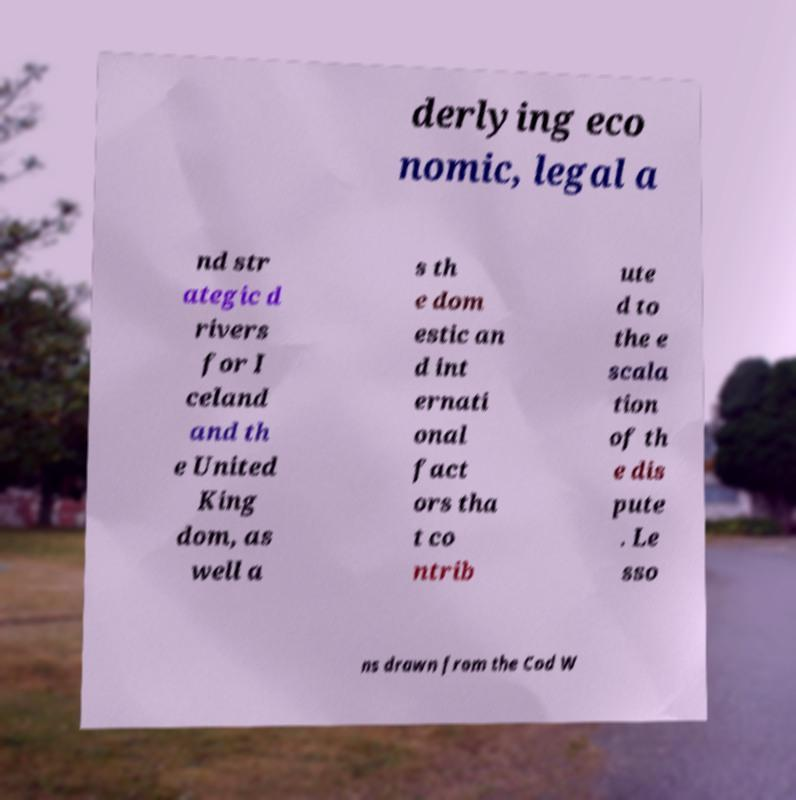Could you extract and type out the text from this image? derlying eco nomic, legal a nd str ategic d rivers for I celand and th e United King dom, as well a s th e dom estic an d int ernati onal fact ors tha t co ntrib ute d to the e scala tion of th e dis pute . Le sso ns drawn from the Cod W 